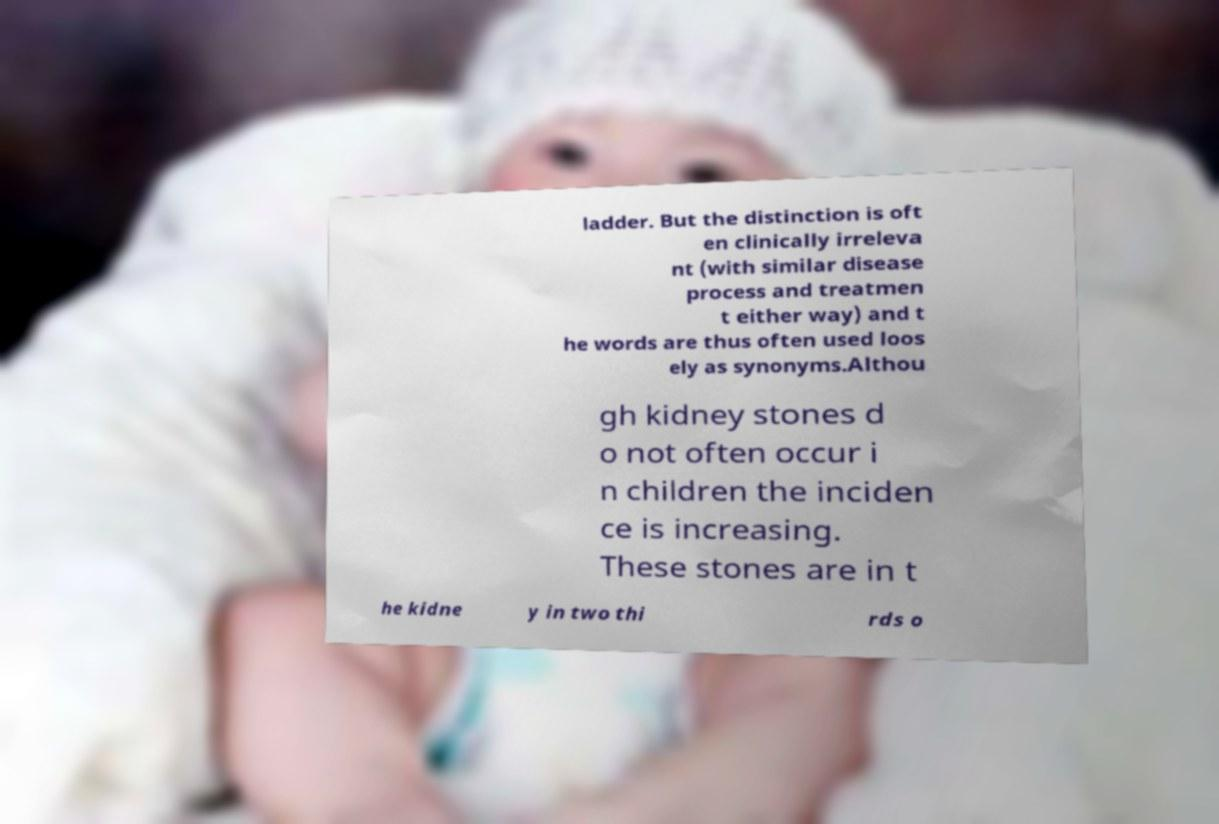Could you extract and type out the text from this image? ladder. But the distinction is oft en clinically irreleva nt (with similar disease process and treatmen t either way) and t he words are thus often used loos ely as synonyms.Althou gh kidney stones d o not often occur i n children the inciden ce is increasing. These stones are in t he kidne y in two thi rds o 